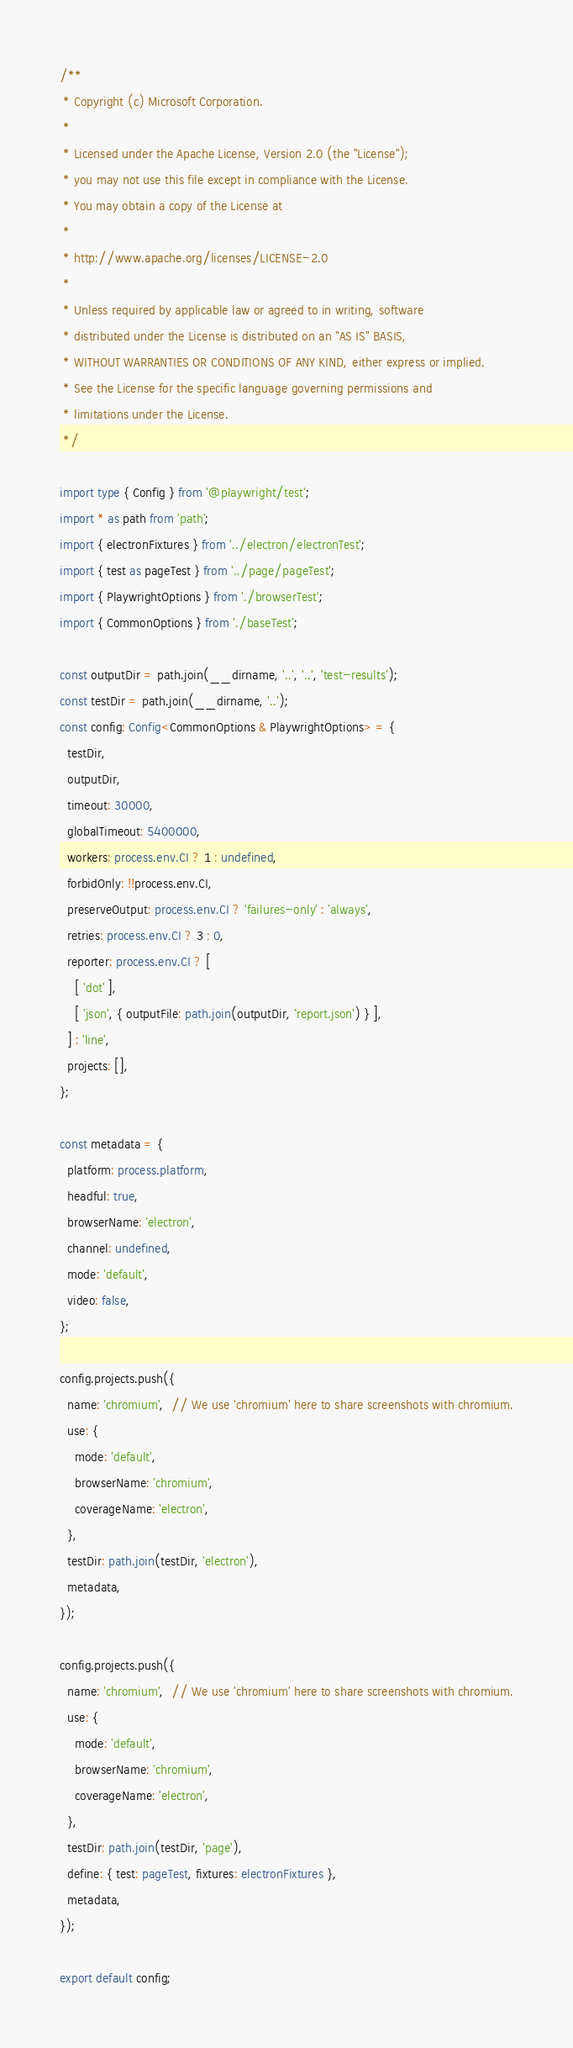<code> <loc_0><loc_0><loc_500><loc_500><_TypeScript_>/**
 * Copyright (c) Microsoft Corporation.
 *
 * Licensed under the Apache License, Version 2.0 (the "License");
 * you may not use this file except in compliance with the License.
 * You may obtain a copy of the License at
 *
 * http://www.apache.org/licenses/LICENSE-2.0
 *
 * Unless required by applicable law or agreed to in writing, software
 * distributed under the License is distributed on an "AS IS" BASIS,
 * WITHOUT WARRANTIES OR CONDITIONS OF ANY KIND, either express or implied.
 * See the License for the specific language governing permissions and
 * limitations under the License.
 */

import type { Config } from '@playwright/test';
import * as path from 'path';
import { electronFixtures } from '../electron/electronTest';
import { test as pageTest } from '../page/pageTest';
import { PlaywrightOptions } from './browserTest';
import { CommonOptions } from './baseTest';

const outputDir = path.join(__dirname, '..', '..', 'test-results');
const testDir = path.join(__dirname, '..');
const config: Config<CommonOptions & PlaywrightOptions> = {
  testDir,
  outputDir,
  timeout: 30000,
  globalTimeout: 5400000,
  workers: process.env.CI ? 1 : undefined,
  forbidOnly: !!process.env.CI,
  preserveOutput: process.env.CI ? 'failures-only' : 'always',
  retries: process.env.CI ? 3 : 0,
  reporter: process.env.CI ? [
    [ 'dot' ],
    [ 'json', { outputFile: path.join(outputDir, 'report.json') } ],
  ] : 'line',
  projects: [],
};

const metadata = {
  platform: process.platform,
  headful: true,
  browserName: 'electron',
  channel: undefined,
  mode: 'default',
  video: false,
};

config.projects.push({
  name: 'chromium',  // We use 'chromium' here to share screenshots with chromium.
  use: {
    mode: 'default',
    browserName: 'chromium',
    coverageName: 'electron',
  },
  testDir: path.join(testDir, 'electron'),
  metadata,
});

config.projects.push({
  name: 'chromium',  // We use 'chromium' here to share screenshots with chromium.
  use: {
    mode: 'default',
    browserName: 'chromium',
    coverageName: 'electron',
  },
  testDir: path.join(testDir, 'page'),
  define: { test: pageTest, fixtures: electronFixtures },
  metadata,
});

export default config;
</code> 